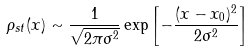<formula> <loc_0><loc_0><loc_500><loc_500>\rho _ { s t } ( x ) \sim \frac { 1 } { \sqrt { 2 \pi \sigma ^ { 2 } } } \exp \left [ - \frac { ( x - x _ { 0 } ) ^ { 2 } } { 2 \sigma ^ { 2 } } \right ]</formula> 